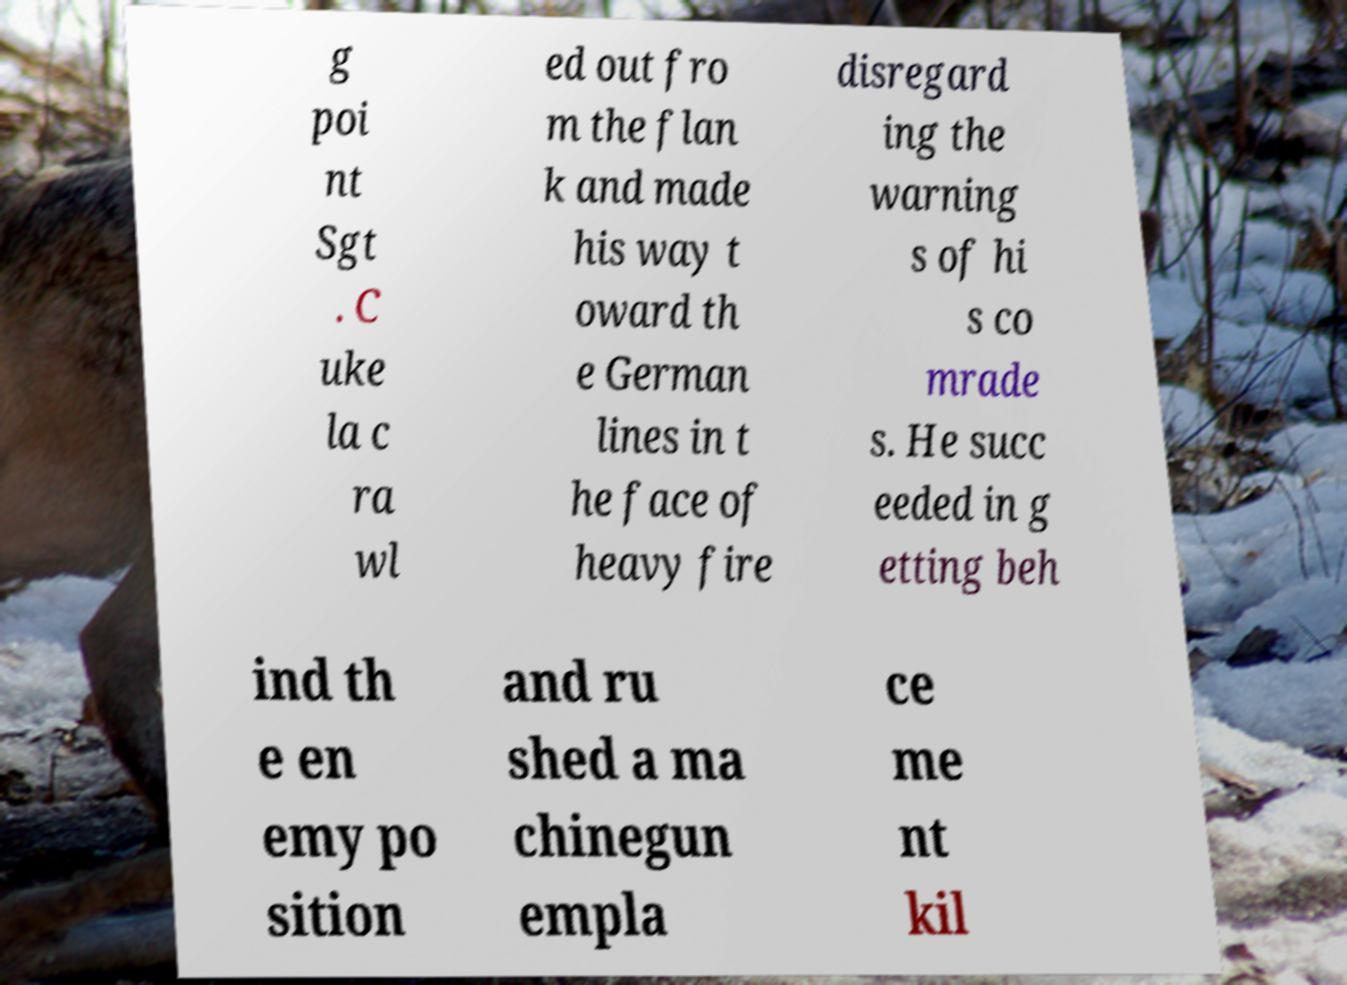Can you accurately transcribe the text from the provided image for me? g poi nt Sgt . C uke la c ra wl ed out fro m the flan k and made his way t oward th e German lines in t he face of heavy fire disregard ing the warning s of hi s co mrade s. He succ eeded in g etting beh ind th e en emy po sition and ru shed a ma chinegun empla ce me nt kil 